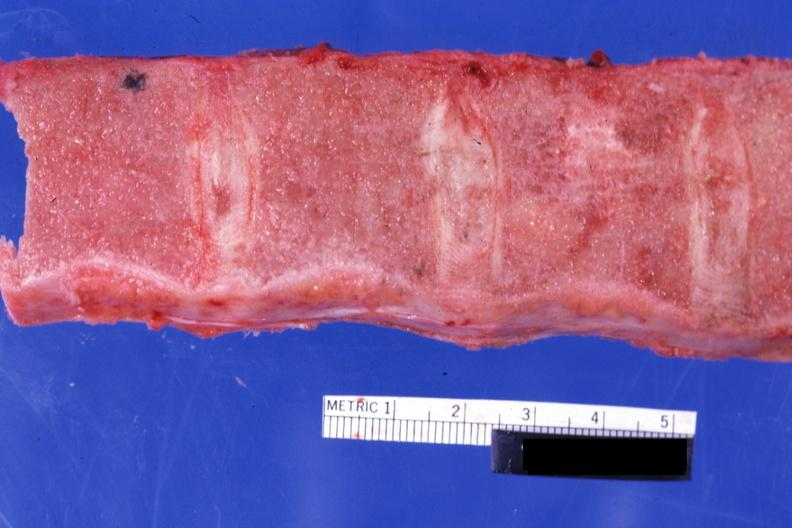where is this part in?
Answer the question using a single word or phrase. Spleen 